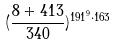<formula> <loc_0><loc_0><loc_500><loc_500>( \frac { 8 + 4 1 3 } { 3 4 0 } ) ^ { 1 9 1 ^ { 9 } \cdot 1 6 3 }</formula> 